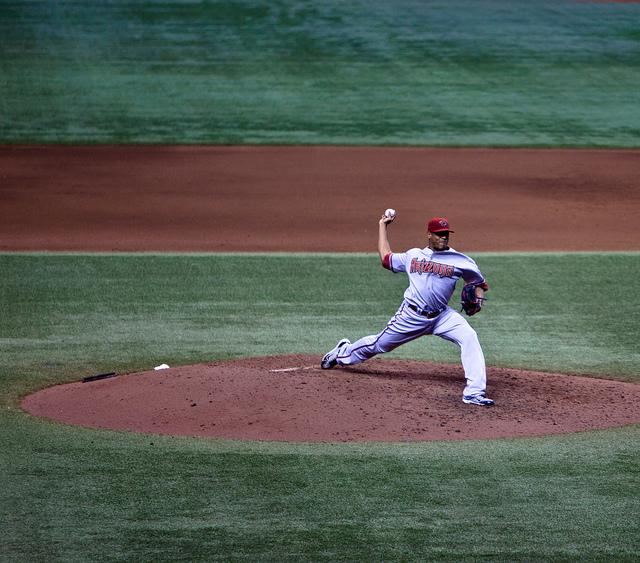What kind of throw is that called?

Choices:
A) pitch
B) underhand
C) hail mary
D) hurl pitch 